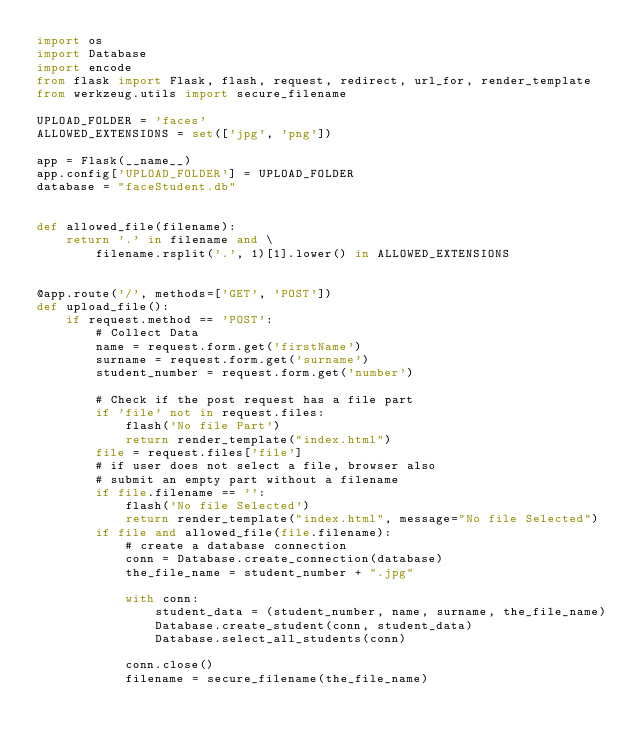Convert code to text. <code><loc_0><loc_0><loc_500><loc_500><_Python_>import os
import Database
import encode
from flask import Flask, flash, request, redirect, url_for, render_template
from werkzeug.utils import secure_filename

UPLOAD_FOLDER = 'faces'
ALLOWED_EXTENSIONS = set(['jpg', 'png'])

app = Flask(__name__)
app.config['UPLOAD_FOLDER'] = UPLOAD_FOLDER
database = "faceStudent.db"


def allowed_file(filename):
    return '.' in filename and \
        filename.rsplit('.', 1)[1].lower() in ALLOWED_EXTENSIONS


@app.route('/', methods=['GET', 'POST'])
def upload_file():
    if request.method == 'POST':
        # Collect Data
        name = request.form.get('firstName')
        surname = request.form.get('surname')
        student_number = request.form.get('number')

        # Check if the post request has a file part
        if 'file' not in request.files:
            flash('No file Part')
            return render_template("index.html")
        file = request.files['file']
        # if user does not select a file, browser also
        # submit an empty part without a filename
        if file.filename == '':
            flash('No file Selected')
            return render_template("index.html", message="No file Selected")
        if file and allowed_file(file.filename):
            # create a database connection
            conn = Database.create_connection(database)
            the_file_name = student_number + ".jpg"

            with conn:
                student_data = (student_number, name, surname, the_file_name)
                Database.create_student(conn, student_data)
                Database.select_all_students(conn)

            conn.close()
            filename = secure_filename(the_file_name)</code> 